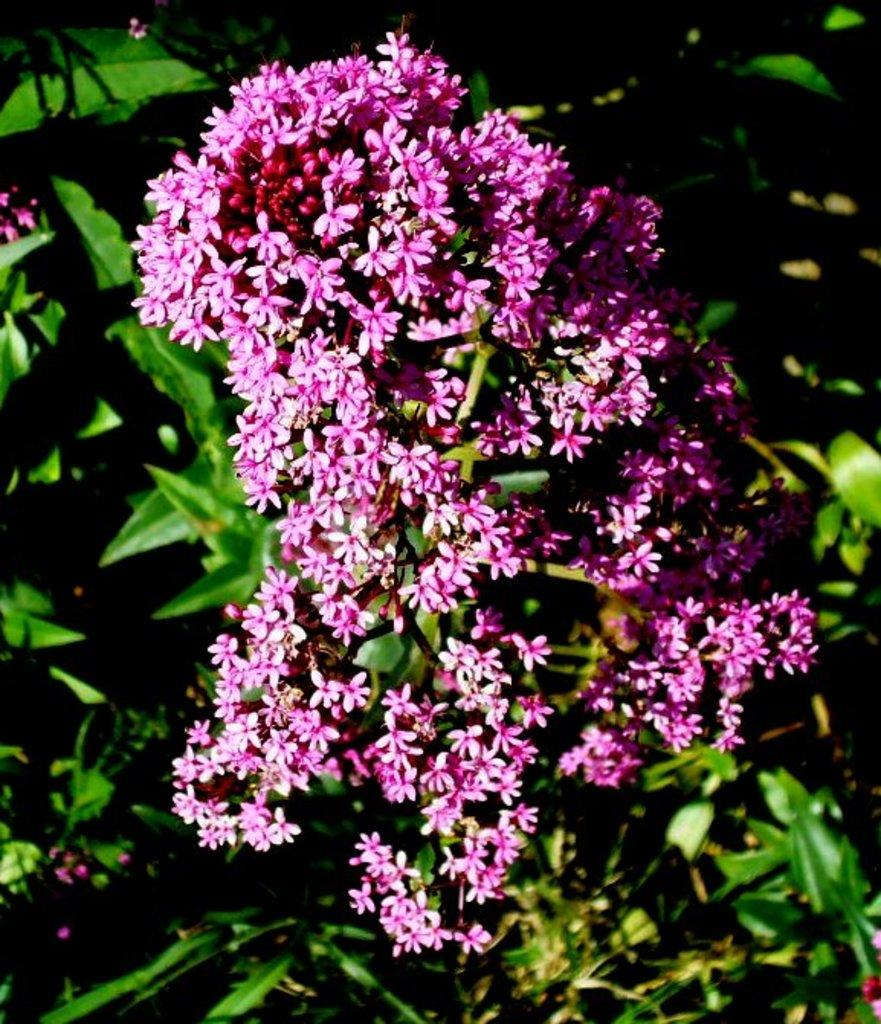What is the main subject of the image? The main subject of the image is a bunch of flowers. Where are the flowers located? The flowers are on a plant. What type of vest is the plant wearing in the image? There is no vest present in the image, as plants do not wear clothing. 